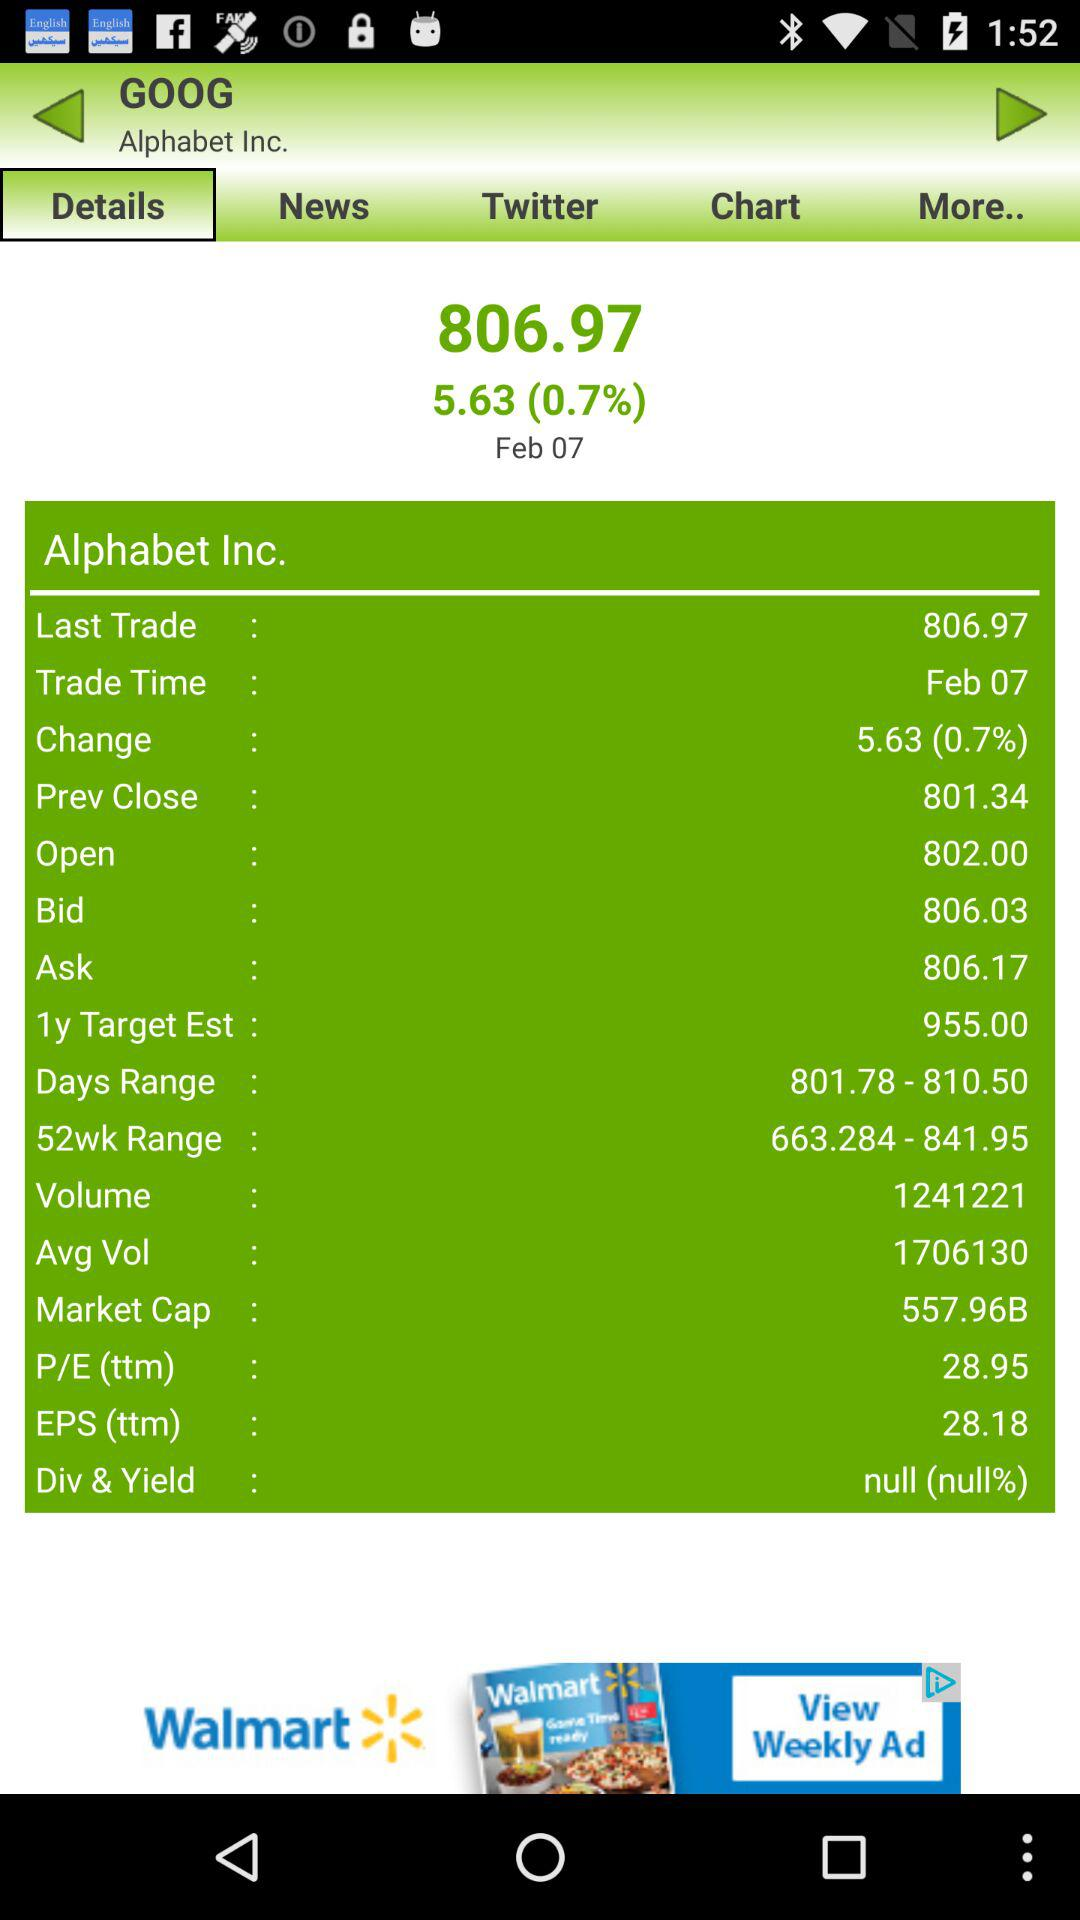What is the price of "1y Target Est" for "Alphabet Inc."? The price of "1y Target Est" for "Alphabet Inc." is 955. 